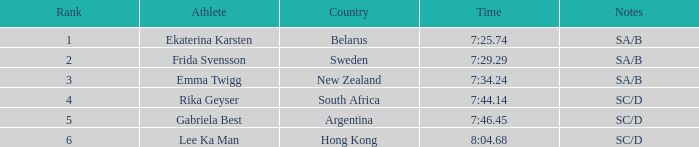24? 1.0. 